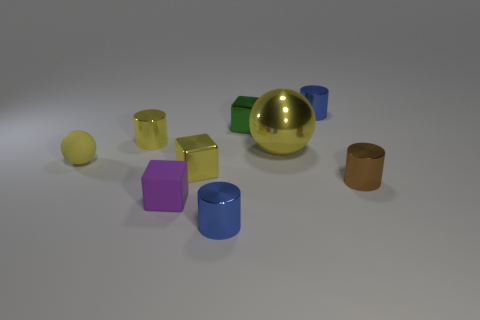How would you describe the lighting in the scene? The lighting in the scene appears to be soft and diffused, with gentle shadows cast underneath the objects. There is a subtle highlight on the surfaces closest to the implied light source, suggesting that the light may be coming from the upper left side of the frame. 